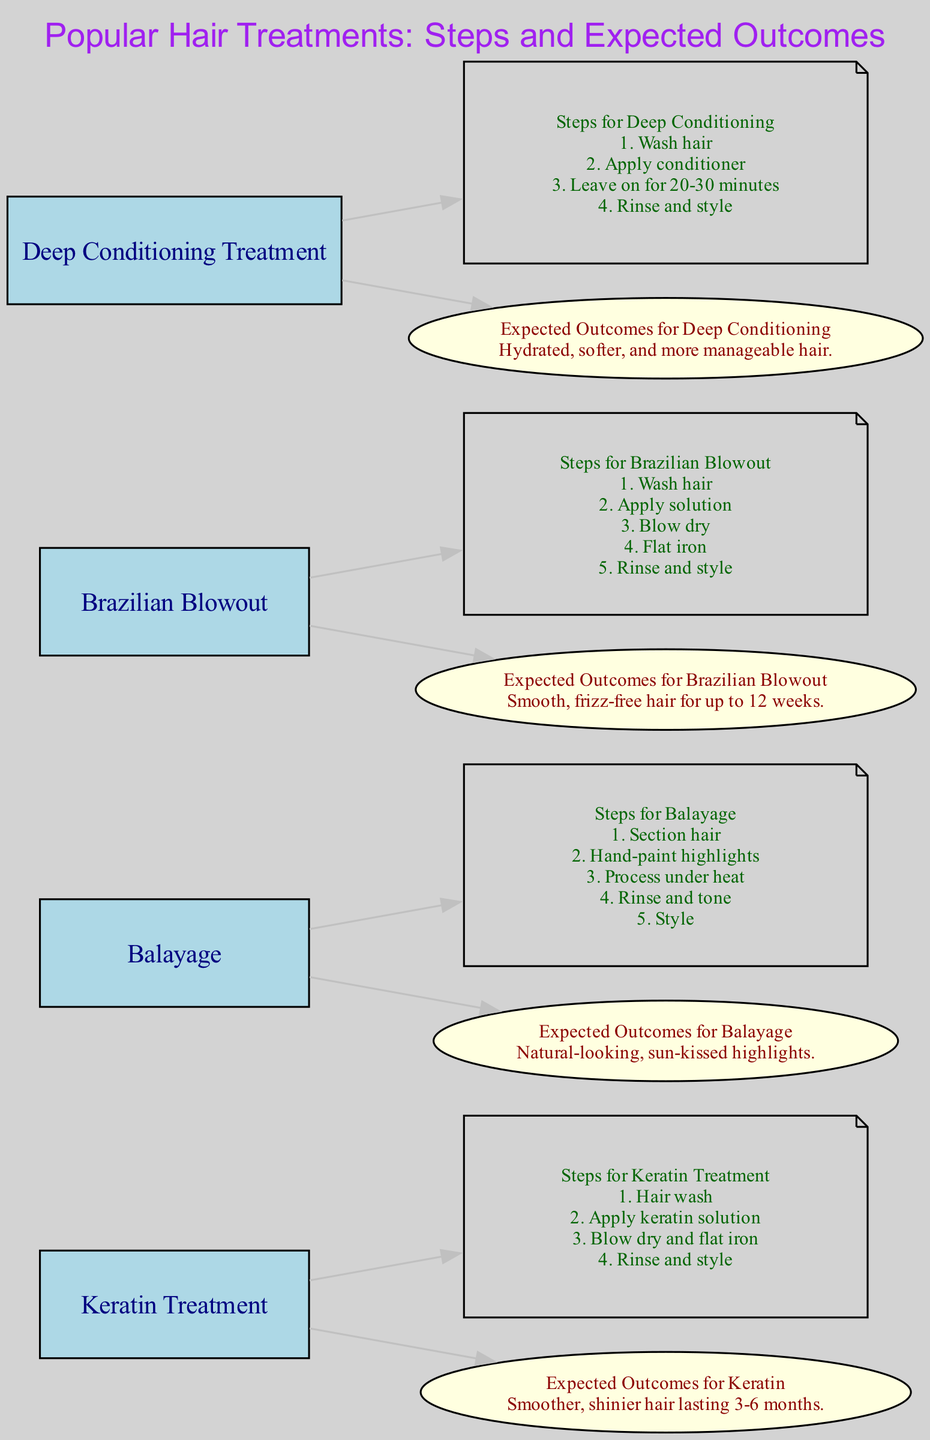What is the first step for a Keratin Treatment? The first step for a Keratin Treatment, as indicated in the diagram, is to wash the hair.
Answer: Hair wash How many nodes represent hair treatments? In the diagram, there are four nodes that represent hair treatments: Keratin Treatment, Balayage, Brazilian Blowout, and Deep Conditioning Treatment.
Answer: Four What is the expected outcome for a Brazilian Blowout? The expected outcome for a Brazilian Blowout, according to the diagram, is smooth and frizz-free hair for up to 12 weeks.
Answer: Smooth, frizz-free hair for up to 12 weeks List one step in the Balayage process. One step in the Balayage process is to hand-paint highlights, which is explicitly mentioned in the steps provided in the diagram.
Answer: Hand-paint highlights Which treatment has an expected outcome of smoother and shinier hair? The Keratin Treatment has an expected outcome of smoother and shinier hair, as noted in the expected outcomes section of the diagram.
Answer: Smoother, shinier hair What is the color representing the steps nodes in the diagram? The steps nodes in the diagram are represented in a note shape with dark green font.
Answer: Dark green What is the total number of edges connecting the treatments to their steps and outcomes? The total number of edges connecting the treatments to their steps and outcomes can be counted as follows: each treatment (4) connects to its steps (4) and expected outcomes (4), making a total of 8 edges.
Answer: Eight Which hair treatment requires applying a solution and flat ironing the hair? The Brazilian Blowout requires applying a solution and flat ironing the hair, as detailed in the steps associated with this treatment in the diagram.
Answer: Brazilian Blowout What type of treatment is Deep Conditioning categorized as in the diagram? The Deep Conditioning treatment is categorized as a moisturizing treatment for repairing dry, damaged hair in the diagram description.
Answer: Moisturizing treatment 